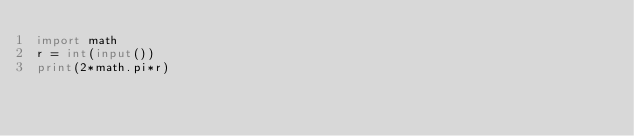Convert code to text. <code><loc_0><loc_0><loc_500><loc_500><_Python_>import math
r = int(input())
print(2*math.pi*r)</code> 